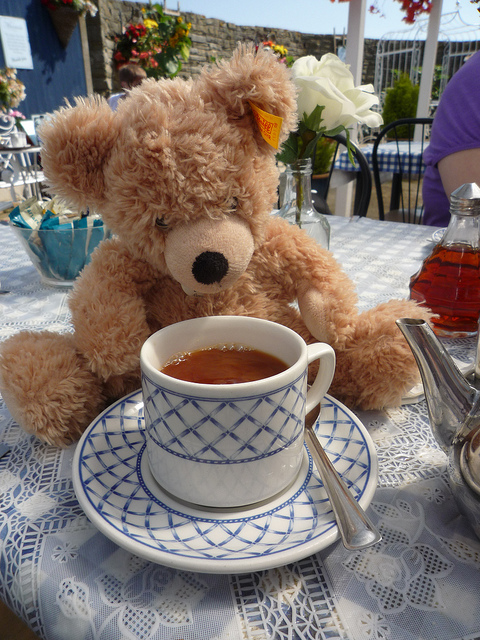Where does the teddy bear come from?
A. germany
B. britain
C. america
D. france
Answer with the option's letter from the given choices directly. The correct answer is C, America. The history of the teddy bear starts in America. It was inspired by an incident involving President Theodore 'Teddy' Roosevelt, who refused to shoot a bear cub during a hunting trip. This act of compassion led to the creation of the teddy bear, named in his honor. 